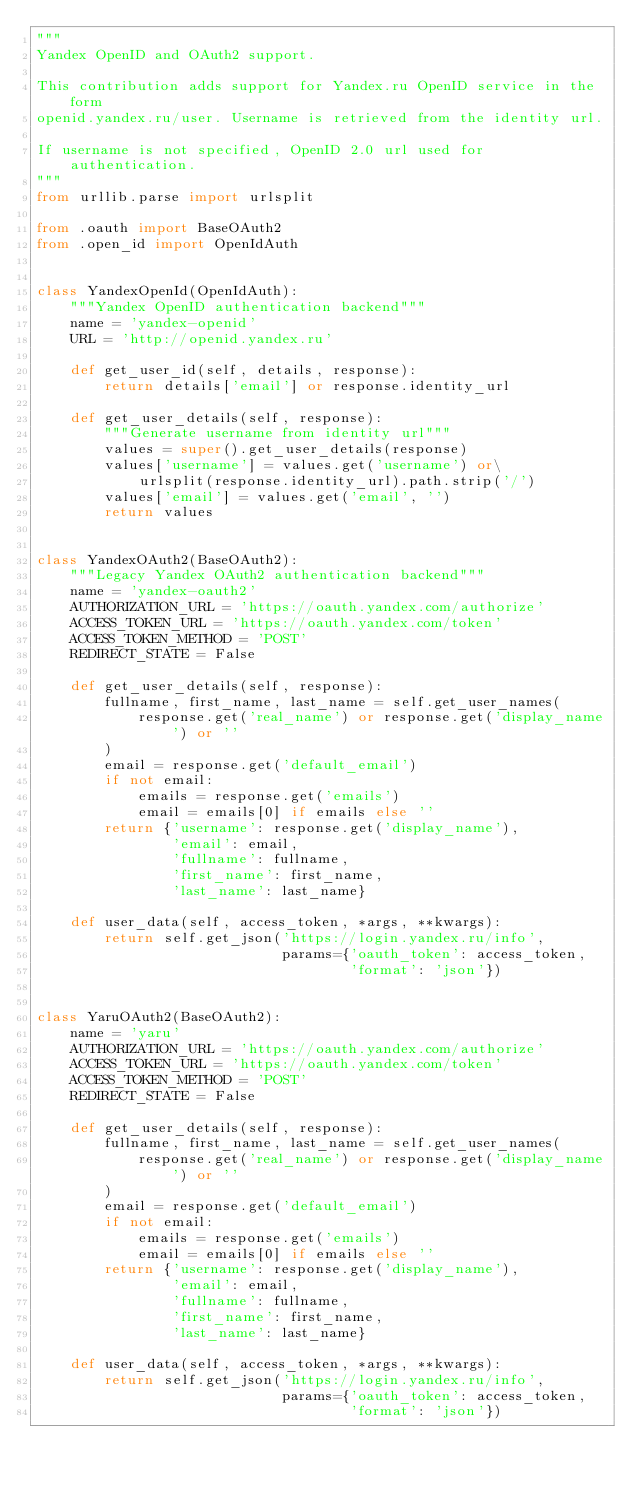Convert code to text. <code><loc_0><loc_0><loc_500><loc_500><_Python_>"""
Yandex OpenID and OAuth2 support.

This contribution adds support for Yandex.ru OpenID service in the form
openid.yandex.ru/user. Username is retrieved from the identity url.

If username is not specified, OpenID 2.0 url used for authentication.
"""
from urllib.parse import urlsplit

from .oauth import BaseOAuth2
from .open_id import OpenIdAuth


class YandexOpenId(OpenIdAuth):
    """Yandex OpenID authentication backend"""
    name = 'yandex-openid'
    URL = 'http://openid.yandex.ru'

    def get_user_id(self, details, response):
        return details['email'] or response.identity_url

    def get_user_details(self, response):
        """Generate username from identity url"""
        values = super().get_user_details(response)
        values['username'] = values.get('username') or\
            urlsplit(response.identity_url).path.strip('/')
        values['email'] = values.get('email', '')
        return values


class YandexOAuth2(BaseOAuth2):
    """Legacy Yandex OAuth2 authentication backend"""
    name = 'yandex-oauth2'
    AUTHORIZATION_URL = 'https://oauth.yandex.com/authorize'
    ACCESS_TOKEN_URL = 'https://oauth.yandex.com/token'
    ACCESS_TOKEN_METHOD = 'POST'
    REDIRECT_STATE = False

    def get_user_details(self, response):
        fullname, first_name, last_name = self.get_user_names(
            response.get('real_name') or response.get('display_name') or ''
        )
        email = response.get('default_email')
        if not email:
            emails = response.get('emails')
            email = emails[0] if emails else ''
        return {'username': response.get('display_name'),
                'email': email,
                'fullname': fullname,
                'first_name': first_name,
                'last_name': last_name}

    def user_data(self, access_token, *args, **kwargs):
        return self.get_json('https://login.yandex.ru/info',
                             params={'oauth_token': access_token,
                                     'format': 'json'})


class YaruOAuth2(BaseOAuth2):
    name = 'yaru'
    AUTHORIZATION_URL = 'https://oauth.yandex.com/authorize'
    ACCESS_TOKEN_URL = 'https://oauth.yandex.com/token'
    ACCESS_TOKEN_METHOD = 'POST'
    REDIRECT_STATE = False

    def get_user_details(self, response):
        fullname, first_name, last_name = self.get_user_names(
            response.get('real_name') or response.get('display_name') or ''
        )
        email = response.get('default_email')
        if not email:
            emails = response.get('emails')
            email = emails[0] if emails else ''
        return {'username': response.get('display_name'),
                'email': email,
                'fullname': fullname,
                'first_name': first_name,
                'last_name': last_name}

    def user_data(self, access_token, *args, **kwargs):
        return self.get_json('https://login.yandex.ru/info',
                             params={'oauth_token': access_token,
                                     'format': 'json'})
</code> 